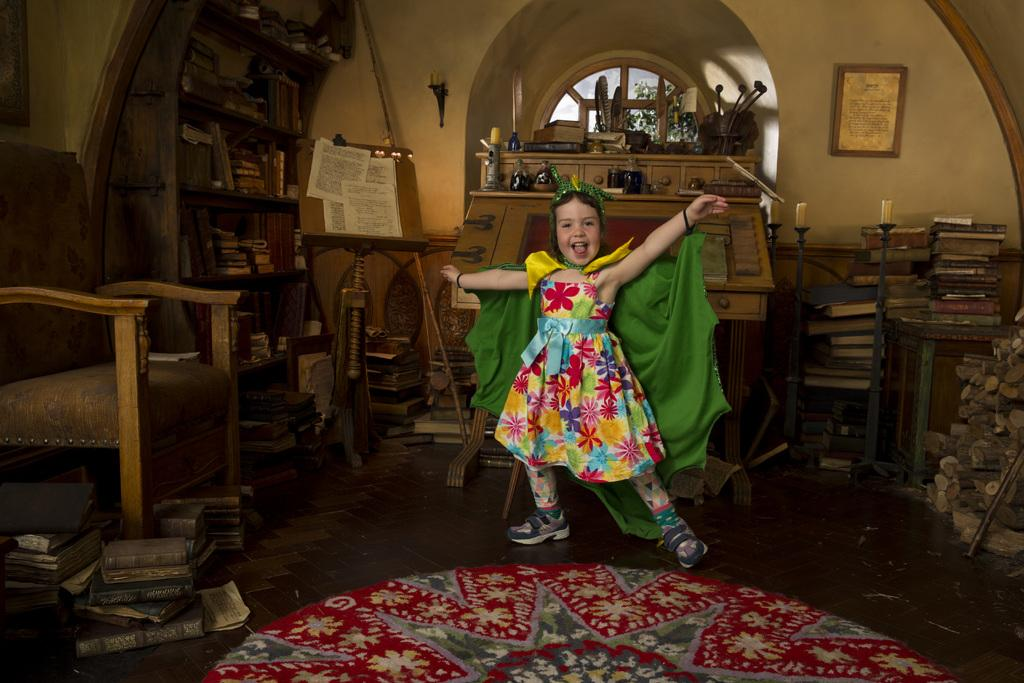Who is present in the image? There is a girl in the image. What is the girl wearing? The girl is wearing a superman costume. What expression does the girl have? The girl is smiling. What objects can be seen on the table in the image? There are books on a table in the image. What type of objects can be seen in the image that emit light? There are candles in the image. What type of objects can be seen in the image that contain liquid? There are bottles in the image. What type of object can be seen in the image that is used for writing or displaying information? There is a board in the image. What type of object can be seen in the image that is used for sitting? There is a chair in the image. What type of object can be seen in the image that is used for storing items? There are racks in the image. What type of object can be seen in the image that allows light to enter the room? There is a window in the image. What type of object can be seen on the wall in the image? There is a frame on the wall in the image. What type of trousers is the girl wearing in the image? The girl is wearing a superman costume, which does not include trousers; it has a bodysuit. 